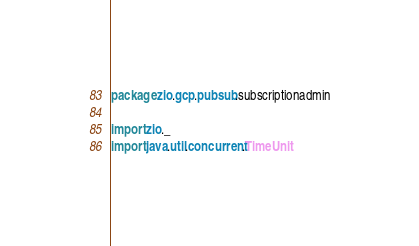Convert code to text. <code><loc_0><loc_0><loc_500><loc_500><_Scala_>package zio.gcp.pubsub.subscriptionadmin

import zio._
import java.util.concurrent.TimeUnit</code> 